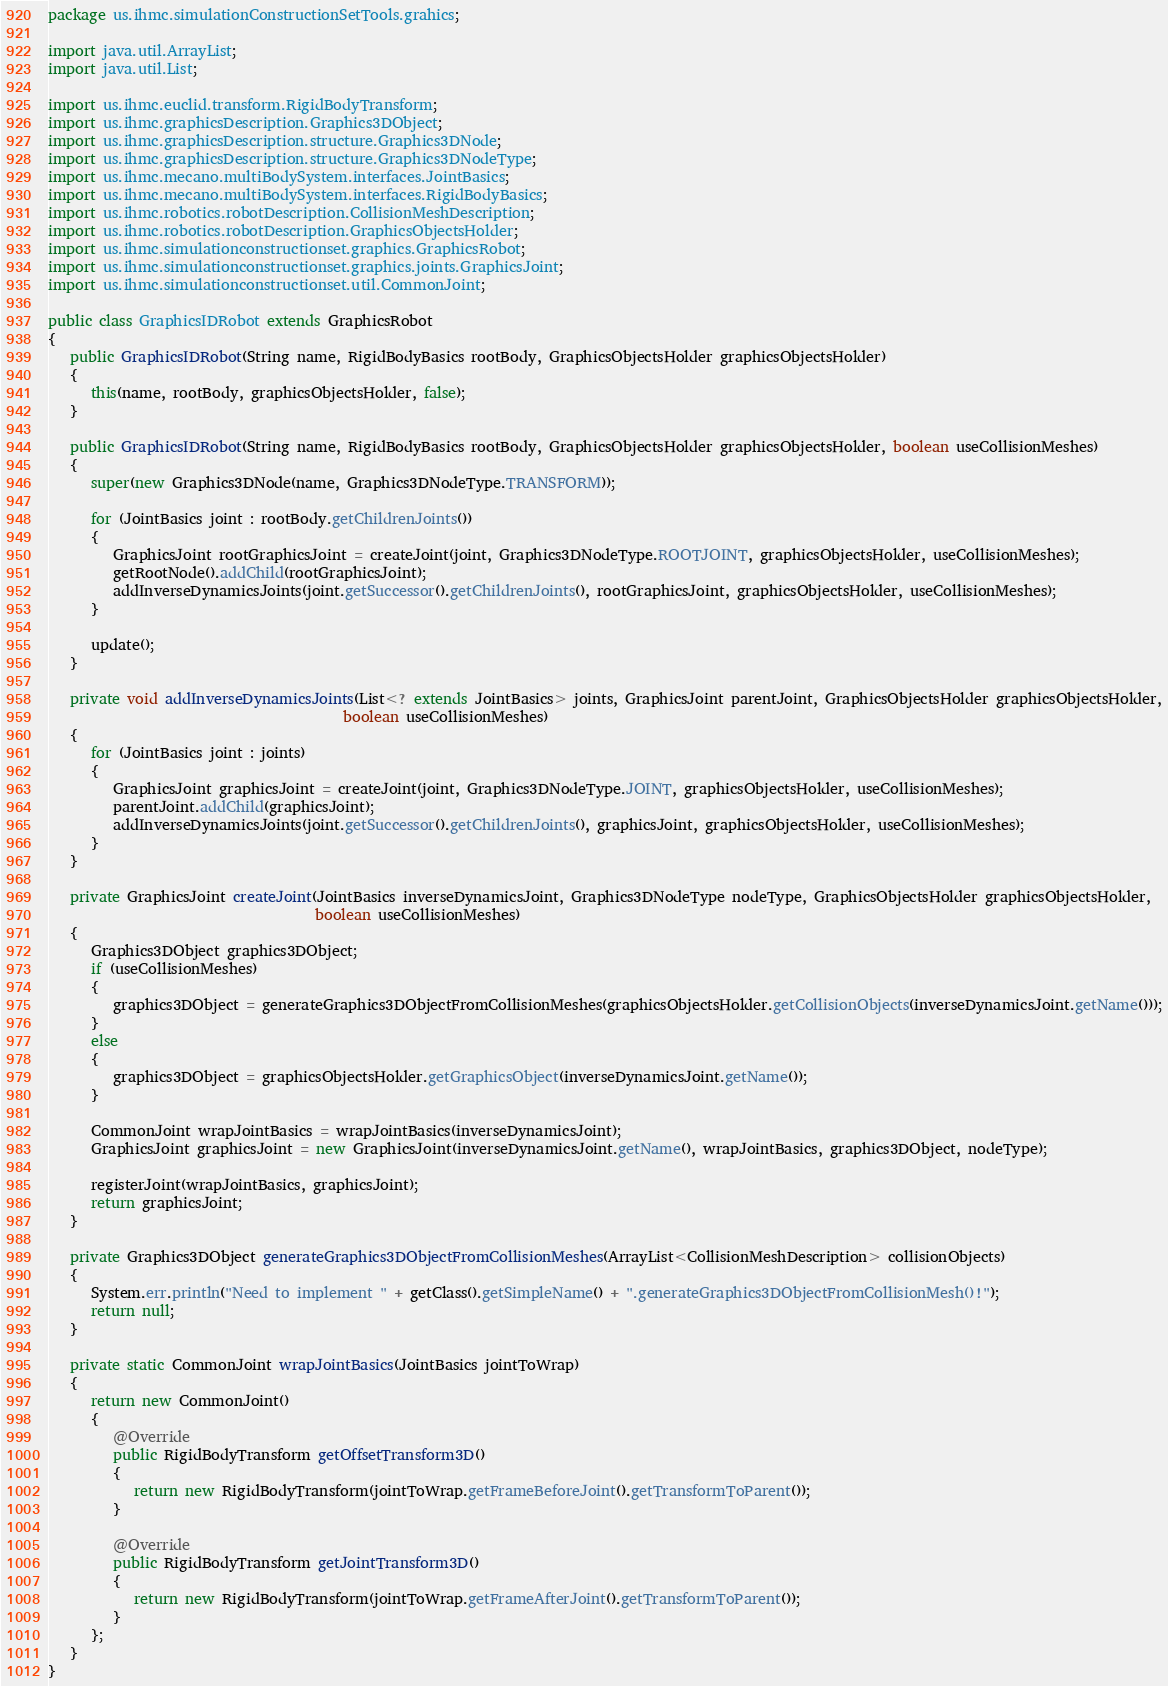Convert code to text. <code><loc_0><loc_0><loc_500><loc_500><_Java_>package us.ihmc.simulationConstructionSetTools.grahics;

import java.util.ArrayList;
import java.util.List;

import us.ihmc.euclid.transform.RigidBodyTransform;
import us.ihmc.graphicsDescription.Graphics3DObject;
import us.ihmc.graphicsDescription.structure.Graphics3DNode;
import us.ihmc.graphicsDescription.structure.Graphics3DNodeType;
import us.ihmc.mecano.multiBodySystem.interfaces.JointBasics;
import us.ihmc.mecano.multiBodySystem.interfaces.RigidBodyBasics;
import us.ihmc.robotics.robotDescription.CollisionMeshDescription;
import us.ihmc.robotics.robotDescription.GraphicsObjectsHolder;
import us.ihmc.simulationconstructionset.graphics.GraphicsRobot;
import us.ihmc.simulationconstructionset.graphics.joints.GraphicsJoint;
import us.ihmc.simulationconstructionset.util.CommonJoint;

public class GraphicsIDRobot extends GraphicsRobot
{
   public GraphicsIDRobot(String name, RigidBodyBasics rootBody, GraphicsObjectsHolder graphicsObjectsHolder)
   {
      this(name, rootBody, graphicsObjectsHolder, false);
   }

   public GraphicsIDRobot(String name, RigidBodyBasics rootBody, GraphicsObjectsHolder graphicsObjectsHolder, boolean useCollisionMeshes)
   {
      super(new Graphics3DNode(name, Graphics3DNodeType.TRANSFORM));

      for (JointBasics joint : rootBody.getChildrenJoints())
      {
         GraphicsJoint rootGraphicsJoint = createJoint(joint, Graphics3DNodeType.ROOTJOINT, graphicsObjectsHolder, useCollisionMeshes);
         getRootNode().addChild(rootGraphicsJoint);
         addInverseDynamicsJoints(joint.getSuccessor().getChildrenJoints(), rootGraphicsJoint, graphicsObjectsHolder, useCollisionMeshes);
      }

      update();
   }

   private void addInverseDynamicsJoints(List<? extends JointBasics> joints, GraphicsJoint parentJoint, GraphicsObjectsHolder graphicsObjectsHolder,
                                         boolean useCollisionMeshes)
   {
      for (JointBasics joint : joints)
      {
         GraphicsJoint graphicsJoint = createJoint(joint, Graphics3DNodeType.JOINT, graphicsObjectsHolder, useCollisionMeshes);
         parentJoint.addChild(graphicsJoint);
         addInverseDynamicsJoints(joint.getSuccessor().getChildrenJoints(), graphicsJoint, graphicsObjectsHolder, useCollisionMeshes);
      }
   }

   private GraphicsJoint createJoint(JointBasics inverseDynamicsJoint, Graphics3DNodeType nodeType, GraphicsObjectsHolder graphicsObjectsHolder,
                                     boolean useCollisionMeshes)
   {
      Graphics3DObject graphics3DObject;
      if (useCollisionMeshes)
      {
         graphics3DObject = generateGraphics3DObjectFromCollisionMeshes(graphicsObjectsHolder.getCollisionObjects(inverseDynamicsJoint.getName()));
      }
      else
      {
         graphics3DObject = graphicsObjectsHolder.getGraphicsObject(inverseDynamicsJoint.getName());
      }

      CommonJoint wrapJointBasics = wrapJointBasics(inverseDynamicsJoint);
      GraphicsJoint graphicsJoint = new GraphicsJoint(inverseDynamicsJoint.getName(), wrapJointBasics, graphics3DObject, nodeType);

      registerJoint(wrapJointBasics, graphicsJoint);
      return graphicsJoint;
   }

   private Graphics3DObject generateGraphics3DObjectFromCollisionMeshes(ArrayList<CollisionMeshDescription> collisionObjects)
   {
      System.err.println("Need to implement " + getClass().getSimpleName() + ".generateGraphics3DObjectFromCollisionMesh()!");
      return null;
   }

   private static CommonJoint wrapJointBasics(JointBasics jointToWrap)
   {
      return new CommonJoint()
      {
         @Override
         public RigidBodyTransform getOffsetTransform3D()
         {
            return new RigidBodyTransform(jointToWrap.getFrameBeforeJoint().getTransformToParent());
         }
         
         @Override
         public RigidBodyTransform getJointTransform3D()
         {
            return new RigidBodyTransform(jointToWrap.getFrameAfterJoint().getTransformToParent());
         }
      };
   }
}
</code> 